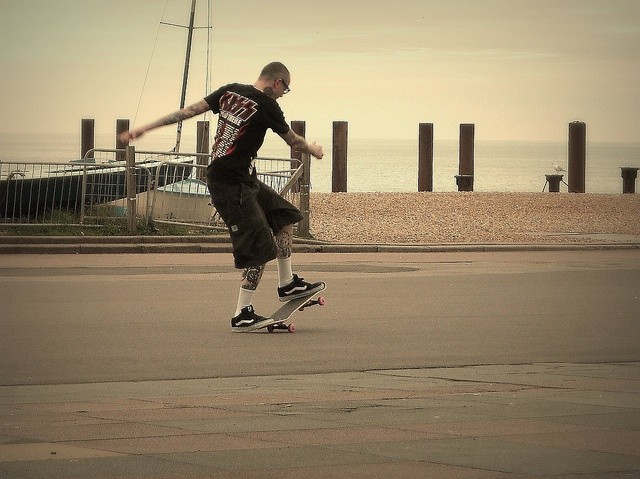Describe the objects in this image and their specific colors. I can see people in darkgray, black, beige, tan, and gray tones, boat in darkgray, black, gray, and tan tones, skateboard in darkgray, gray, and black tones, and bird in darkgray, tan, and gray tones in this image. 